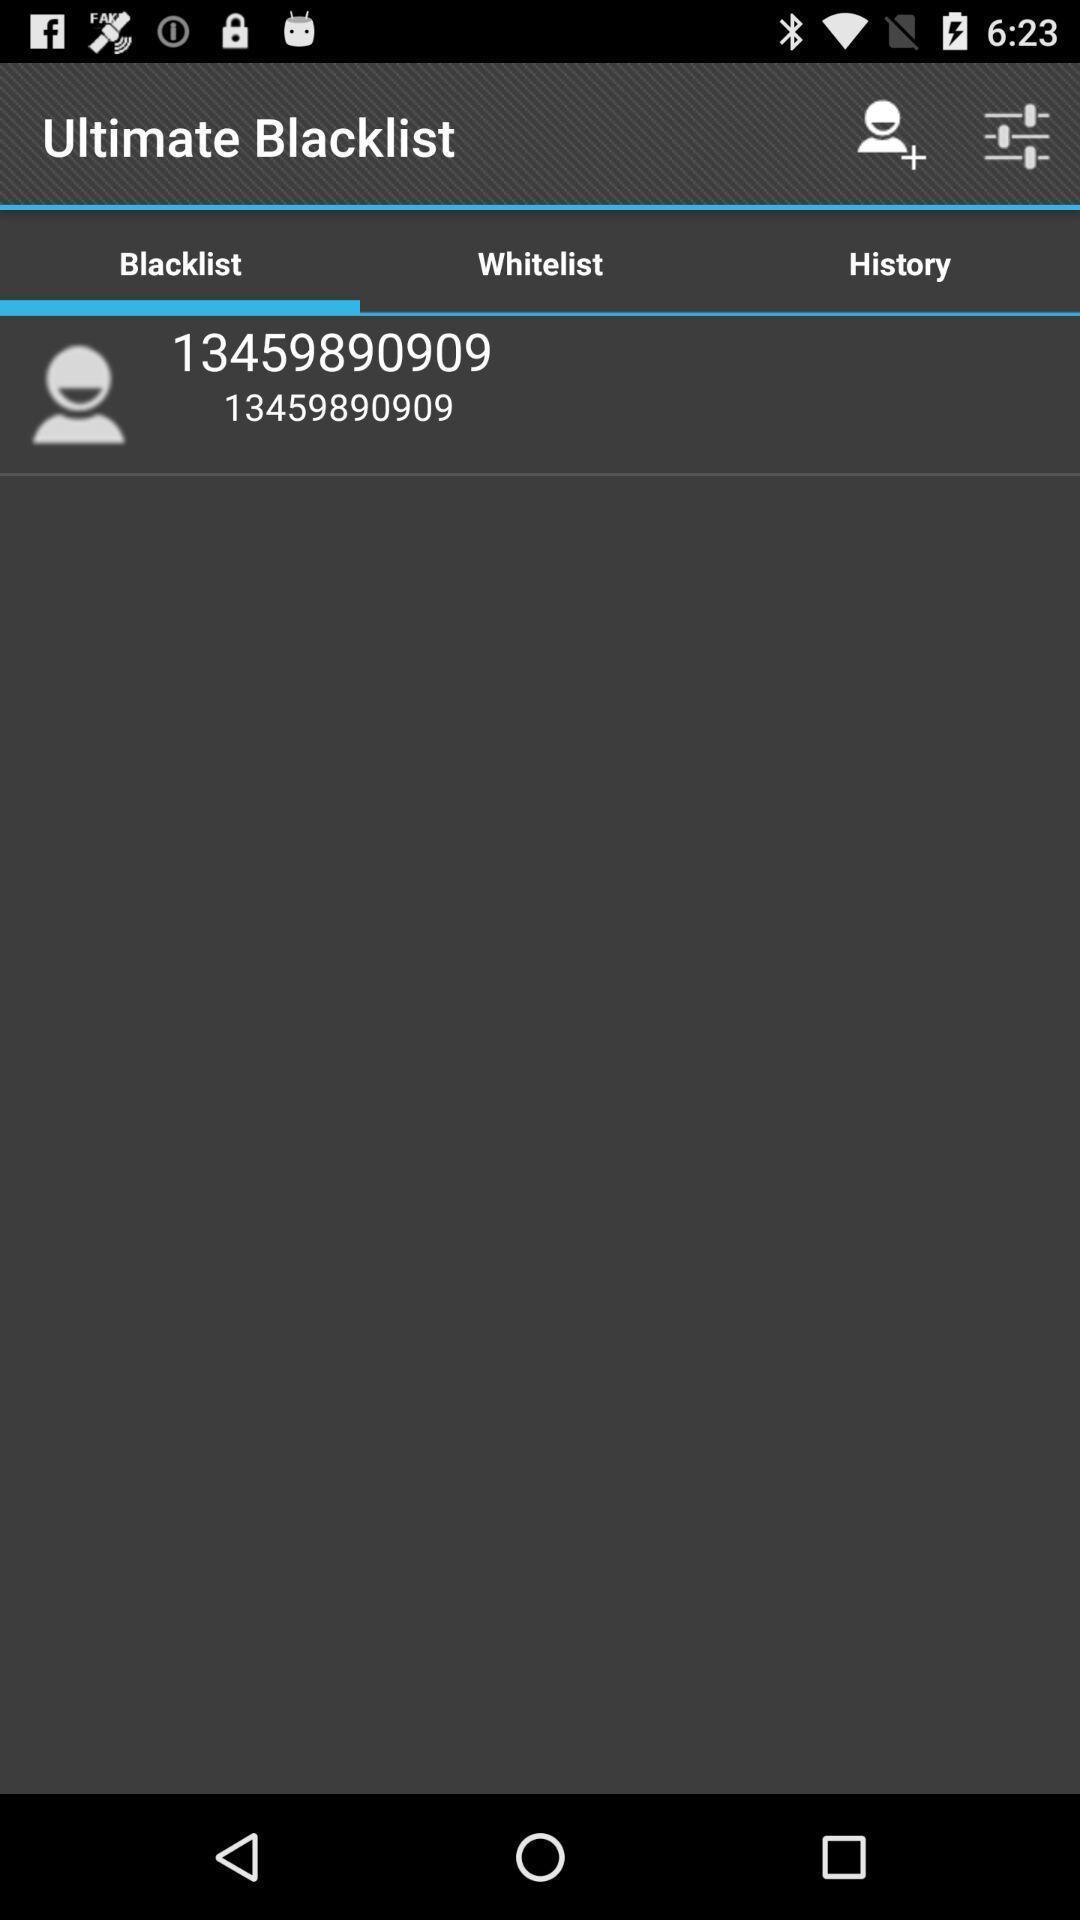Provide a description of this screenshot. Page showing blacklist on app. 